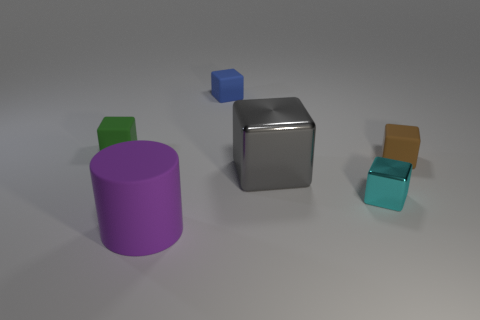Are there any red blocks that have the same material as the tiny cyan thing?
Give a very brief answer. No. There is a thing that is to the left of the matte thing that is in front of the rubber block that is in front of the small green object; what is its color?
Provide a short and direct response. Green. How many brown objects are either small spheres or large rubber cylinders?
Your answer should be very brief. 0. How many other large purple things are the same shape as the purple rubber thing?
Give a very brief answer. 0. There is a green rubber object that is the same size as the brown thing; what is its shape?
Ensure brevity in your answer.  Cube. There is a cylinder; are there any small brown matte cubes in front of it?
Provide a succinct answer. No. Are there any purple cylinders that are to the left of the big thing to the left of the blue matte block?
Offer a very short reply. No. Is the number of big cylinders in front of the cylinder less than the number of cyan shiny objects that are behind the green cube?
Ensure brevity in your answer.  No. What is the shape of the large gray metal thing?
Offer a very short reply. Cube. What is the large gray thing in front of the tiny blue rubber cube made of?
Your answer should be compact. Metal. 